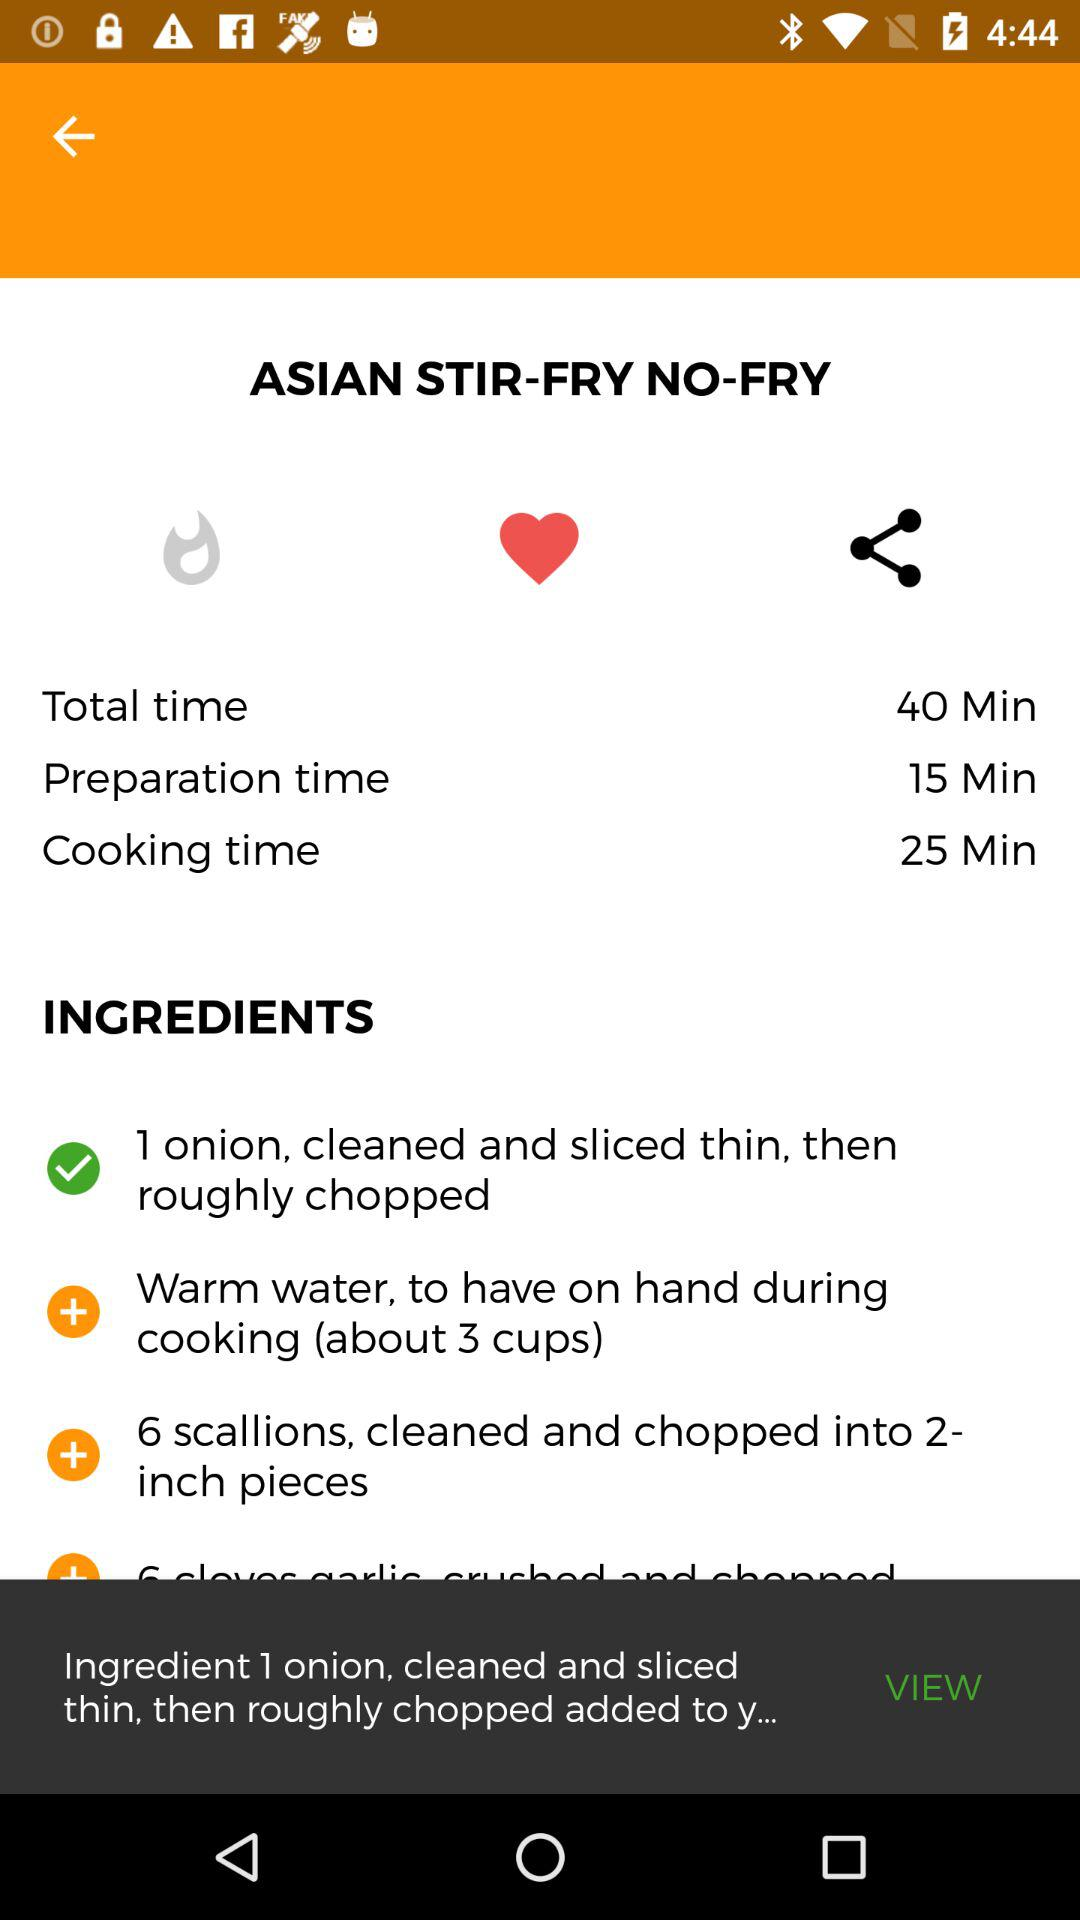What is the total time? The total time is 40 minutes. 